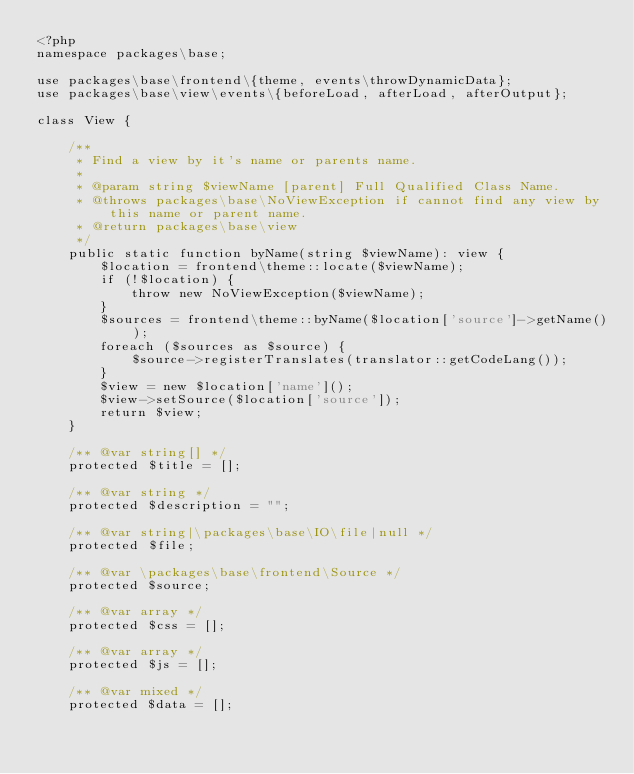Convert code to text. <code><loc_0><loc_0><loc_500><loc_500><_PHP_><?php
namespace packages\base;

use packages\base\frontend\{theme, events\throwDynamicData};
use packages\base\view\events\{beforeLoad, afterLoad, afterOutput};

class View {

	/**
	 * Find a view by it's name or parents name.
	 * 
	 * @param string $viewName [parent] Full Qualified Class Name.
	 * @throws packages\base\NoViewException if cannot find any view by this name or parent name.
	 * @return packages\base\view
	 */
	public static function byName(string $viewName): view {
		$location = frontend\theme::locate($viewName);
		if (!$location) {
			throw new NoViewException($viewName); 
		}
		$sources = frontend\theme::byName($location['source']->getName());
		foreach ($sources as $source) {
			$source->registerTranslates(translator::getCodeLang());
		}
		$view = new $location['name']();
		$view->setSource($location['source']);
		return $view;
	}

	/** @var string[] */
	protected $title = [];
	
	/** @var string */
	protected $description = "";

	/** @var string|\packages\base\IO\file|null */
	protected $file;

	/** @var \packages\base\frontend\Source */
	protected $source;

	/** @var array */
	protected $css = [];

	/** @var array */
	protected $js = [];

	/** @var mixed */
	protected $data = [];
</code> 